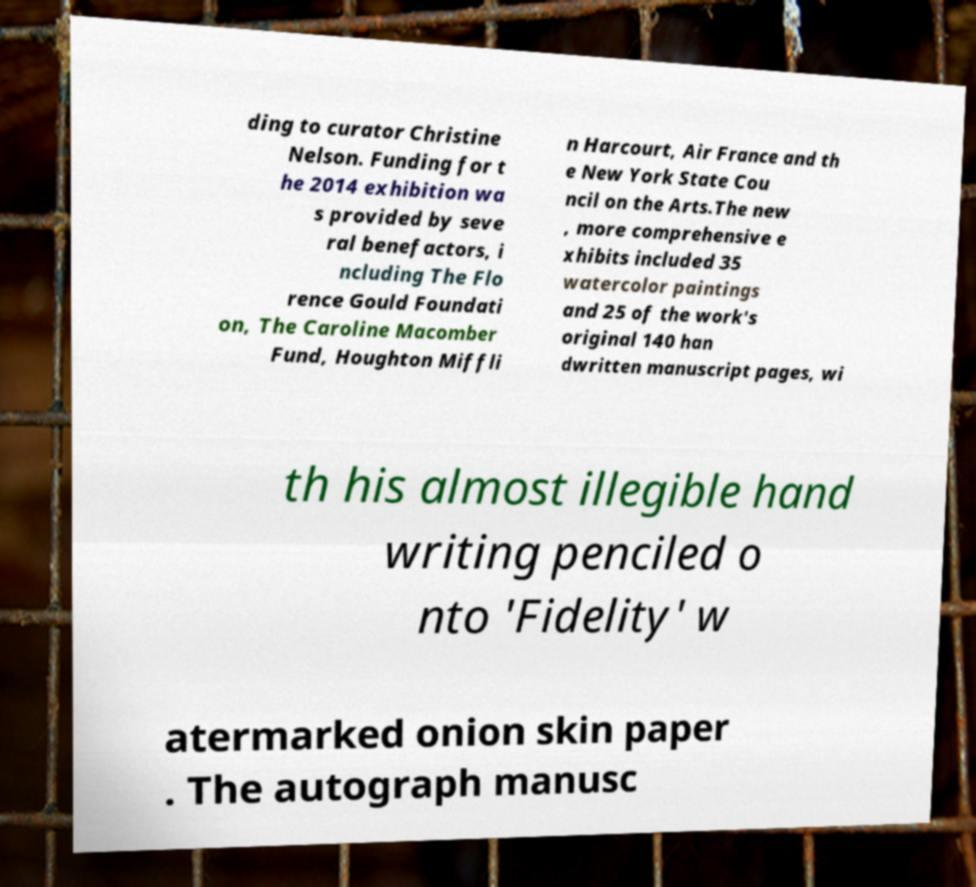Could you assist in decoding the text presented in this image and type it out clearly? ding to curator Christine Nelson. Funding for t he 2014 exhibition wa s provided by seve ral benefactors, i ncluding The Flo rence Gould Foundati on, The Caroline Macomber Fund, Houghton Miffli n Harcourt, Air France and th e New York State Cou ncil on the Arts.The new , more comprehensive e xhibits included 35 watercolor paintings and 25 of the work's original 140 han dwritten manuscript pages, wi th his almost illegible hand writing penciled o nto 'Fidelity' w atermarked onion skin paper . The autograph manusc 